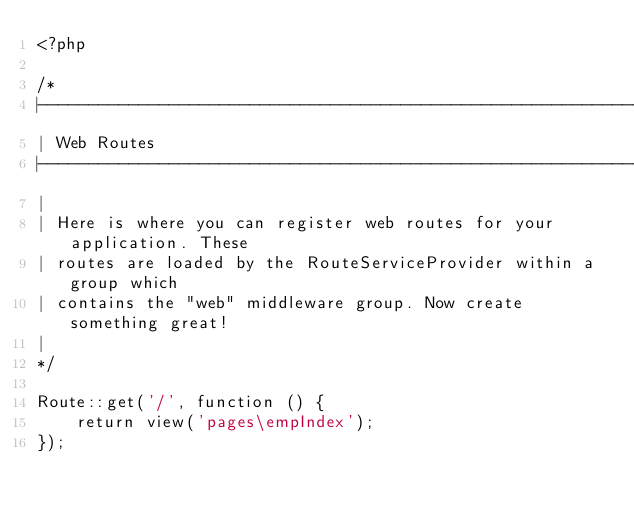Convert code to text. <code><loc_0><loc_0><loc_500><loc_500><_PHP_><?php

/*
|--------------------------------------------------------------------------
| Web Routes
|--------------------------------------------------------------------------
|
| Here is where you can register web routes for your application. These
| routes are loaded by the RouteServiceProvider within a group which
| contains the "web" middleware group. Now create something great!
|
*/

Route::get('/', function () {
    return view('pages\empIndex');
});
</code> 